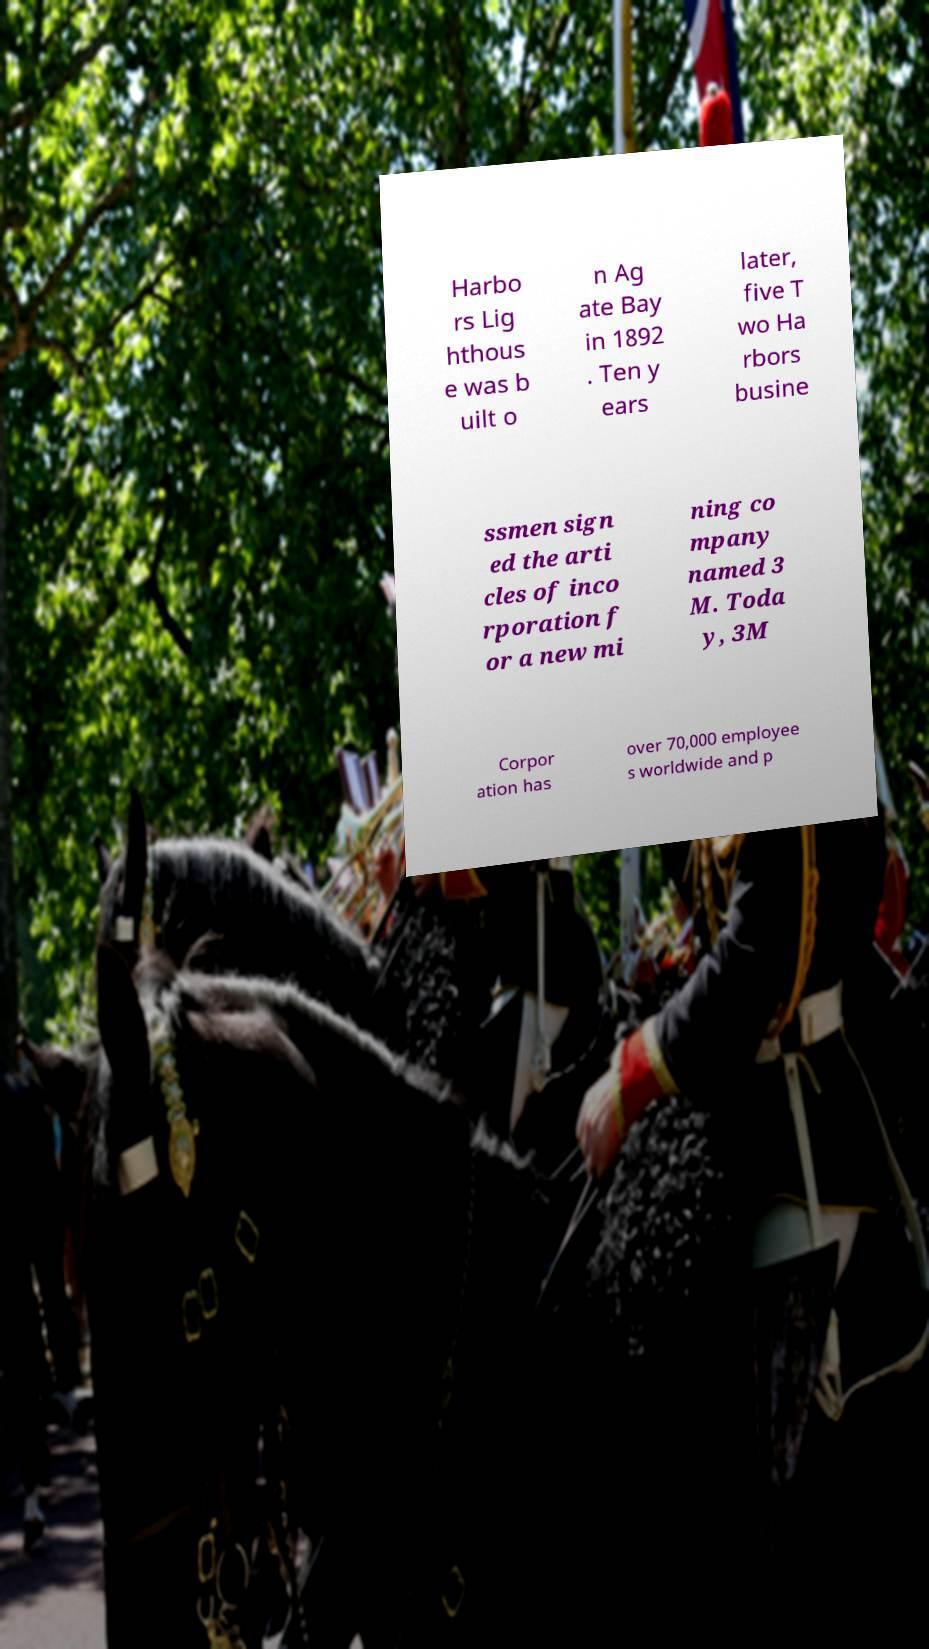Can you accurately transcribe the text from the provided image for me? Harbo rs Lig hthous e was b uilt o n Ag ate Bay in 1892 . Ten y ears later, five T wo Ha rbors busine ssmen sign ed the arti cles of inco rporation f or a new mi ning co mpany named 3 M. Toda y, 3M Corpor ation has over 70,000 employee s worldwide and p 